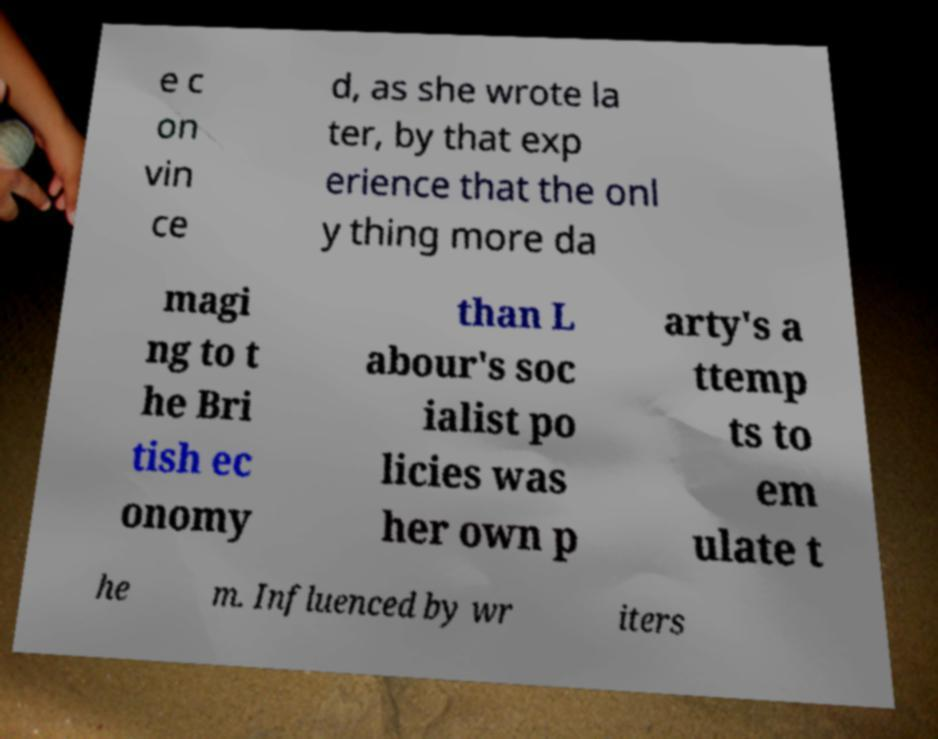Can you accurately transcribe the text from the provided image for me? e c on vin ce d, as she wrote la ter, by that exp erience that the onl y thing more da magi ng to t he Bri tish ec onomy than L abour's soc ialist po licies was her own p arty's a ttemp ts to em ulate t he m. Influenced by wr iters 